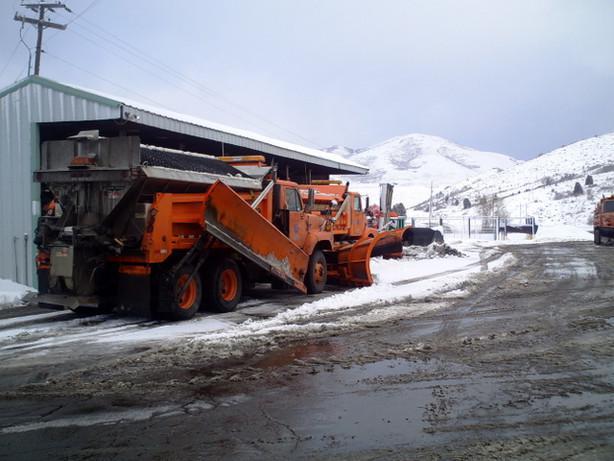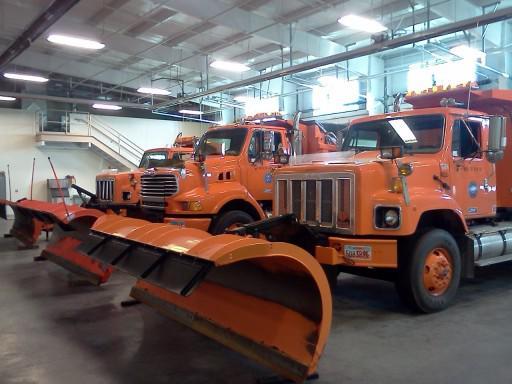The first image is the image on the left, the second image is the image on the right. For the images displayed, is the sentence "The road in the image on the left is cleared of snow, while the snow is still being cleared in the image on the right." factually correct? Answer yes or no. No. The first image is the image on the left, the second image is the image on the right. For the images shown, is this caption "Exactly one snow plow is plowing snow." true? Answer yes or no. No. 